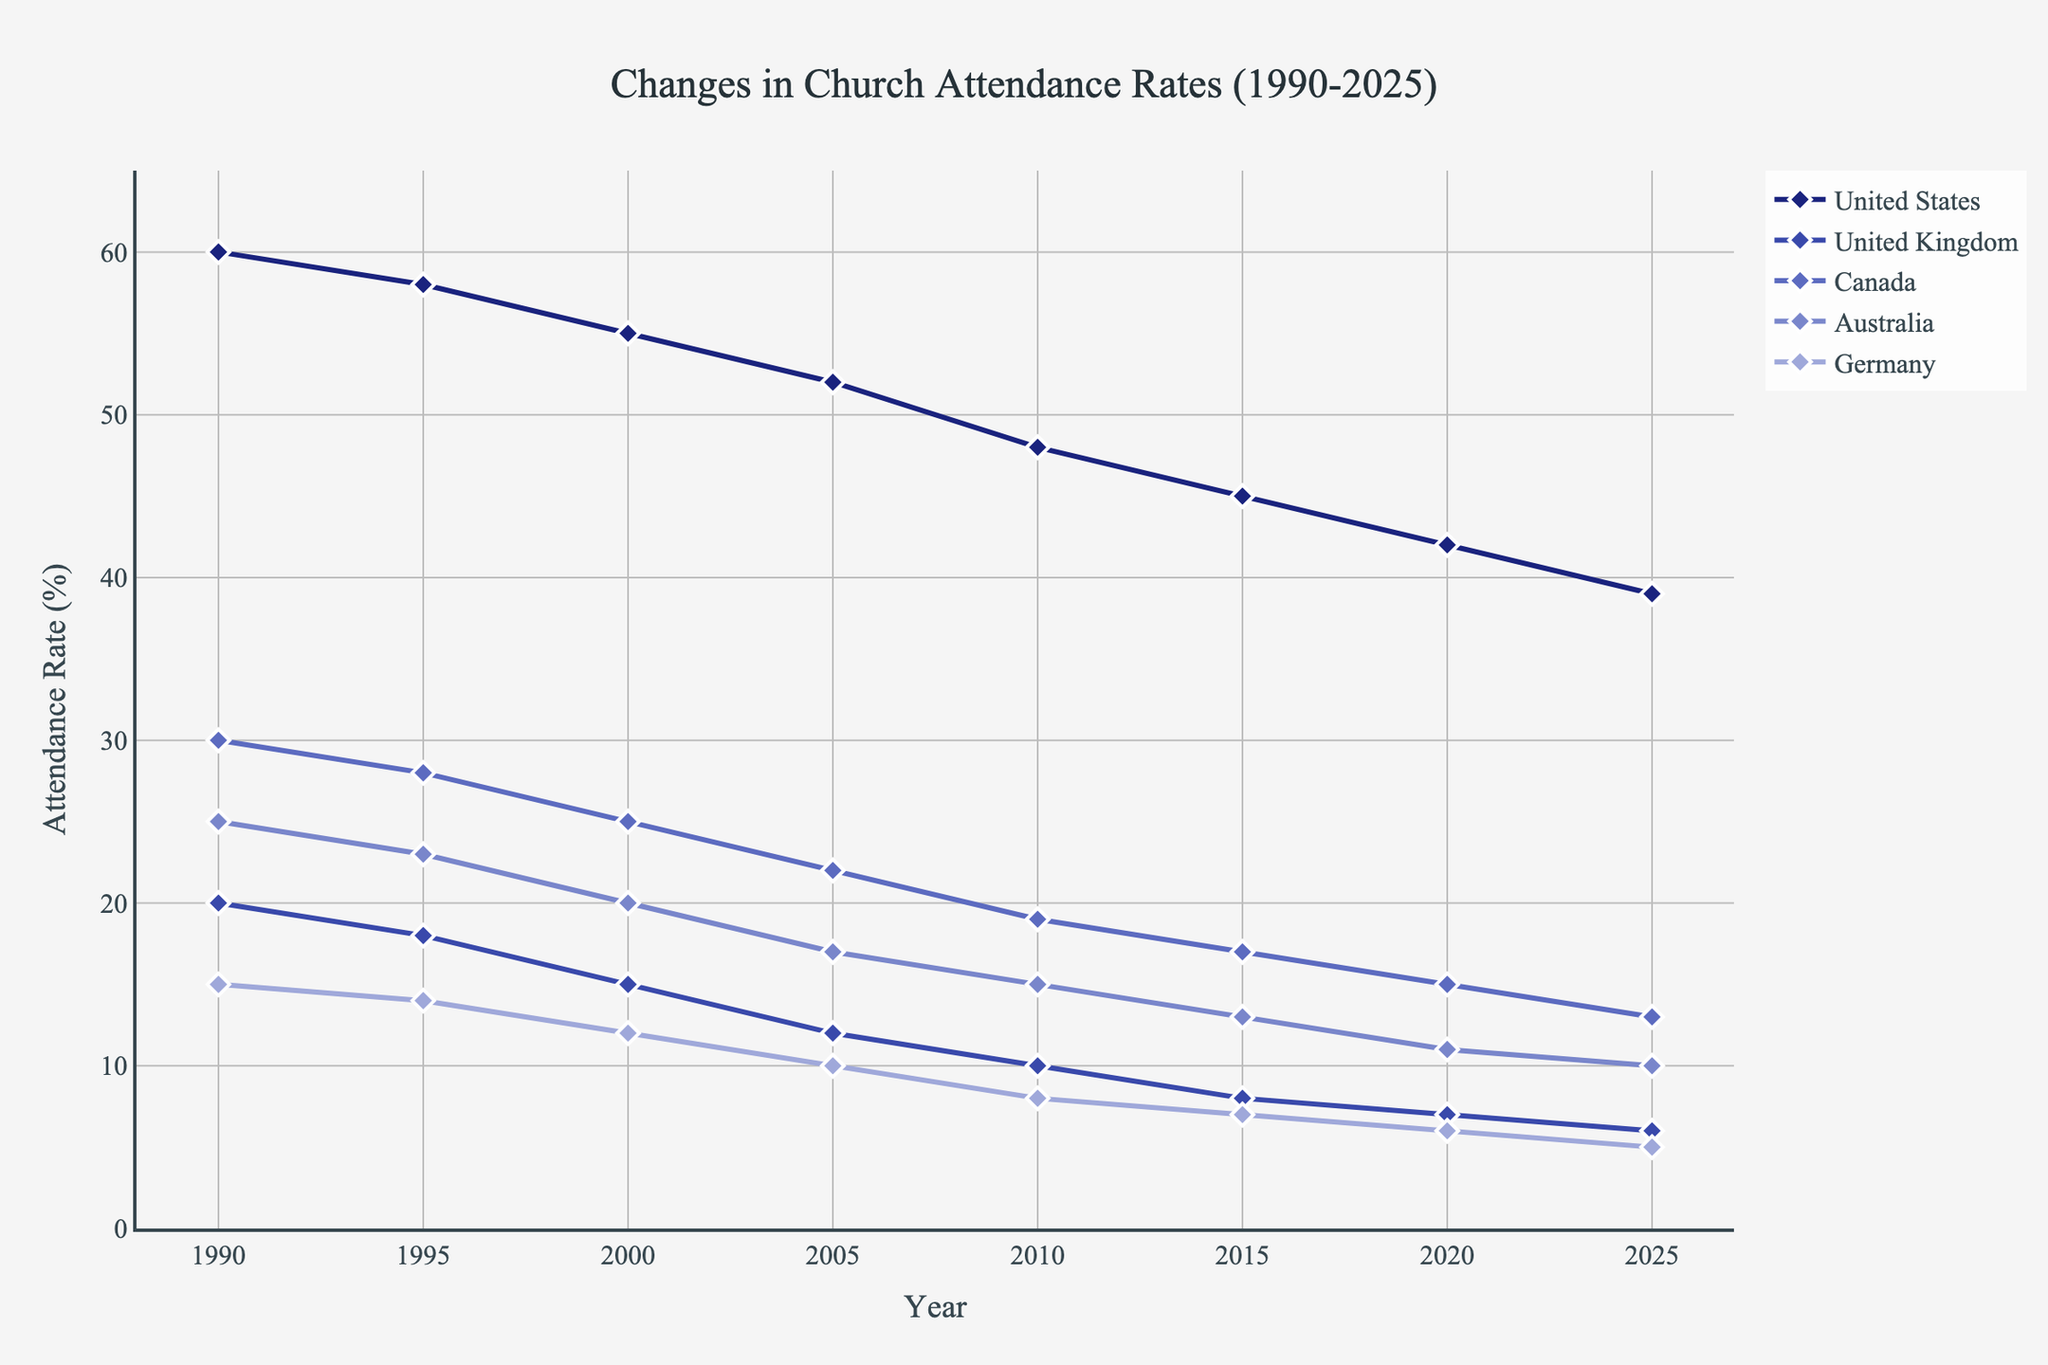Which country shows the steepest decline in church attendance from 1990 to 2025? Identify the country with the greatest decrease by observing the slopes. The United States starts at an attendance rate of 60% and ends at 39%, which is a 21 point drop. The United Kingdom starts at 20% and drops to 6%, a 14 point drop. Canada, Australia, and Germany have smaller drops. So, the United States has the steepest decline.
Answer: United States Which country has the lowest church attendance rate in 2025? Look at the rates in 2025 for each country on the x-axis. The lowest rate is the one for Germany at 5%.
Answer: Germany What is the approximate average decrease in church attendance for Australia from 1990 to 2025? Subtract the attendance rate in 2025 from the rate in 1990 and divide by the number of years between them. The decrease is 25% - 10% = 15%. The average annual decrease is 15% / 35 years ≈ 0.429%.
Answer: 0.429% How does the church attendance rate in the United Kingdom in 2000 compare to that in the United States in 2020? Compare the values given on the y-axis for both years. The UK in 2000 has an attendance rate of 15%, while the US in 2020 has an attendance rate of 42%. So the US rate in 2020 is higher.
Answer: United States is higher Between which two consecutive years does Canada see the largest drop in church attendance? Examine the slope of the line representing Canada. The largest drop appears between 1990 to 1995, where the rate decreases from 30% to 28% (2 points), but the steeper drop happens between 1995 to 2000 from 28% to 25% (3 points).
Answer: 1995-2000 Which year does Australia’s church attendance rate first fall below 15%? Track the trend line for Australia until it crosses below the 15% mark. This happens between 2010 and 2015; thus, it first falls below 15% in 2015.
Answer: 2015 For which country is the color purple used to represent its attendance rate? The color purple is associated with Canada, as its line color in the chart matches the description in the figure generation code.
Answer: Canada What is the combined church attendance rate for the United States and Australia in 1990? Add the attendance rates of the United States and Australia in 1990. The US rate is 60%, and Australia's rate is 25%. Combined, it's 60% + 25% = 85%.
Answer: 85% How does the decline in church attendance in Germany compare to that in Canada from 2000 to 2020? Calculate the decline for both countries between these years. Germany's rate drops from 12% to 6% (a 6 point drop), while Canada's drops from 25% to 15% (a 10 point drop). Canada's decline is greater.
Answer: Canada's decline is greater 